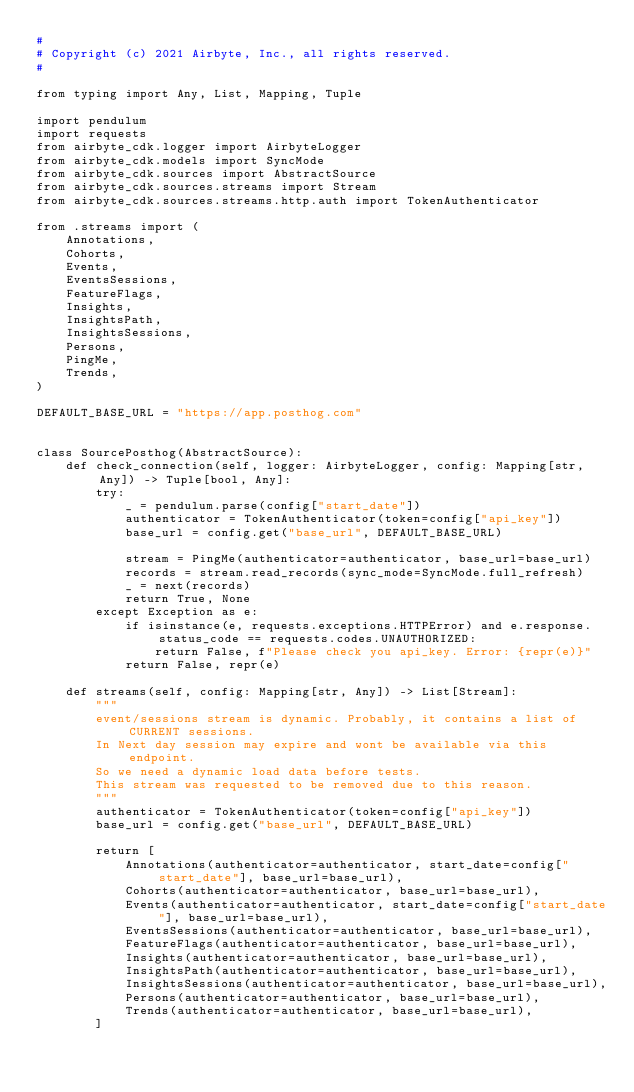<code> <loc_0><loc_0><loc_500><loc_500><_Python_>#
# Copyright (c) 2021 Airbyte, Inc., all rights reserved.
#

from typing import Any, List, Mapping, Tuple

import pendulum
import requests
from airbyte_cdk.logger import AirbyteLogger
from airbyte_cdk.models import SyncMode
from airbyte_cdk.sources import AbstractSource
from airbyte_cdk.sources.streams import Stream
from airbyte_cdk.sources.streams.http.auth import TokenAuthenticator

from .streams import (
    Annotations,
    Cohorts,
    Events,
    EventsSessions,
    FeatureFlags,
    Insights,
    InsightsPath,
    InsightsSessions,
    Persons,
    PingMe,
    Trends,
)

DEFAULT_BASE_URL = "https://app.posthog.com"


class SourcePosthog(AbstractSource):
    def check_connection(self, logger: AirbyteLogger, config: Mapping[str, Any]) -> Tuple[bool, Any]:
        try:
            _ = pendulum.parse(config["start_date"])
            authenticator = TokenAuthenticator(token=config["api_key"])
            base_url = config.get("base_url", DEFAULT_BASE_URL)

            stream = PingMe(authenticator=authenticator, base_url=base_url)
            records = stream.read_records(sync_mode=SyncMode.full_refresh)
            _ = next(records)
            return True, None
        except Exception as e:
            if isinstance(e, requests.exceptions.HTTPError) and e.response.status_code == requests.codes.UNAUTHORIZED:
                return False, f"Please check you api_key. Error: {repr(e)}"
            return False, repr(e)

    def streams(self, config: Mapping[str, Any]) -> List[Stream]:
        """
        event/sessions stream is dynamic. Probably, it contains a list of CURRENT sessions.
        In Next day session may expire and wont be available via this endpoint.
        So we need a dynamic load data before tests.
        This stream was requested to be removed due to this reason.
        """
        authenticator = TokenAuthenticator(token=config["api_key"])
        base_url = config.get("base_url", DEFAULT_BASE_URL)

        return [
            Annotations(authenticator=authenticator, start_date=config["start_date"], base_url=base_url),
            Cohorts(authenticator=authenticator, base_url=base_url),
            Events(authenticator=authenticator, start_date=config["start_date"], base_url=base_url),
            EventsSessions(authenticator=authenticator, base_url=base_url),
            FeatureFlags(authenticator=authenticator, base_url=base_url),
            Insights(authenticator=authenticator, base_url=base_url),
            InsightsPath(authenticator=authenticator, base_url=base_url),
            InsightsSessions(authenticator=authenticator, base_url=base_url),
            Persons(authenticator=authenticator, base_url=base_url),
            Trends(authenticator=authenticator, base_url=base_url),
        ]
</code> 